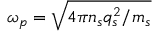<formula> <loc_0><loc_0><loc_500><loc_500>\omega _ { p } = \sqrt { 4 \pi n _ { s } q _ { s } ^ { 2 } / m _ { s } }</formula> 